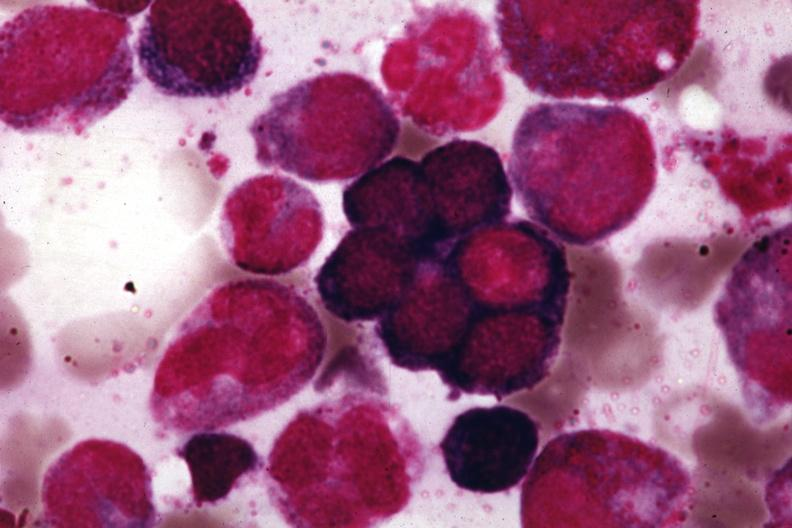s bone marrow present?
Answer the question using a single word or phrase. Yes 